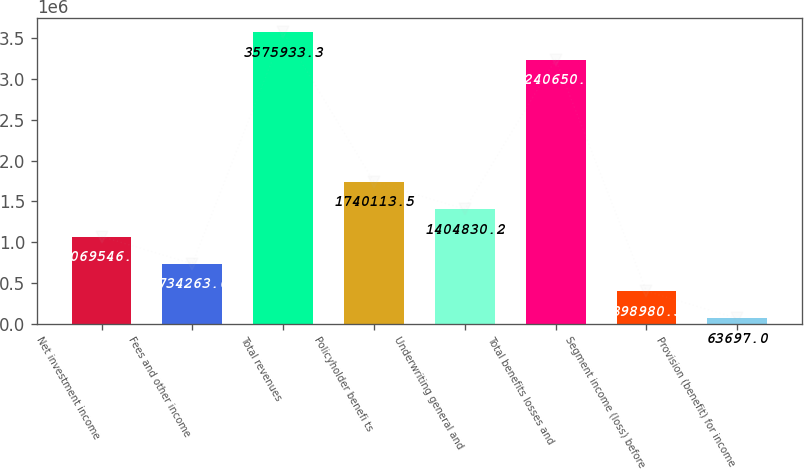<chart> <loc_0><loc_0><loc_500><loc_500><bar_chart><fcel>Net investment income<fcel>Fees and other income<fcel>Total revenues<fcel>Policyholder benefi ts<fcel>Underwriting general and<fcel>Total benefits losses and<fcel>Segment income (loss) before<fcel>Provision (benefit) for income<nl><fcel>1.06955e+06<fcel>734264<fcel>3.57593e+06<fcel>1.74011e+06<fcel>1.40483e+06<fcel>3.24065e+06<fcel>398980<fcel>63697<nl></chart> 